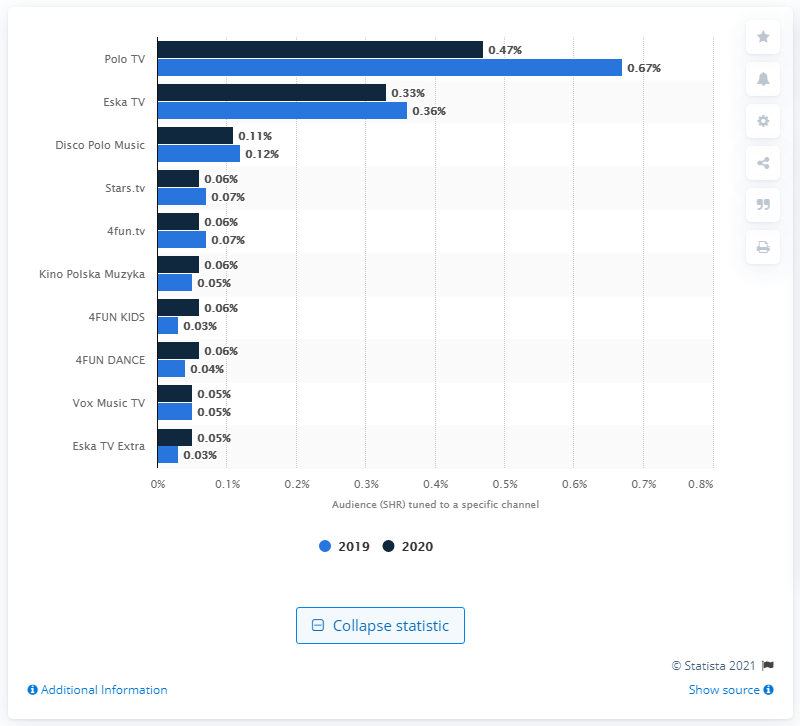Indicate a few pertinent items in this graphic. In 2020, Polo TV was the leading music TV channel in Poland. 